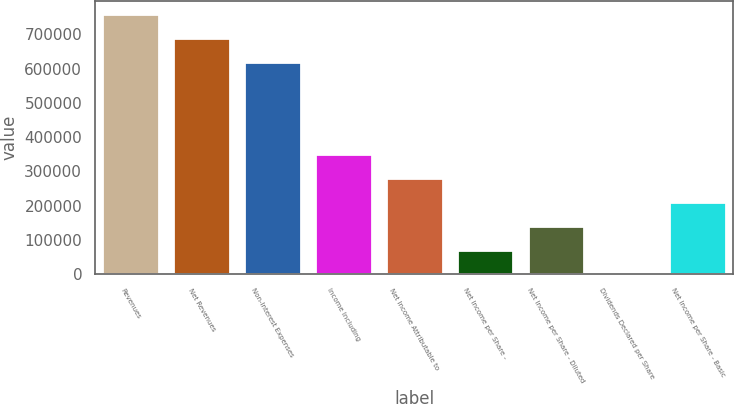<chart> <loc_0><loc_0><loc_500><loc_500><bar_chart><fcel>Revenues<fcel>Net Revenues<fcel>Non-Interest Expenses<fcel>Income Including<fcel>Net Income Attributable to<fcel>Net Income per Share -<fcel>Net Income per Share - Diluted<fcel>Dividends Declared per Share<fcel>Net Income per Share - Basic<nl><fcel>760388<fcel>690121<fcel>619854<fcel>351335<fcel>281068<fcel>70267<fcel>140534<fcel>0.11<fcel>210801<nl></chart> 